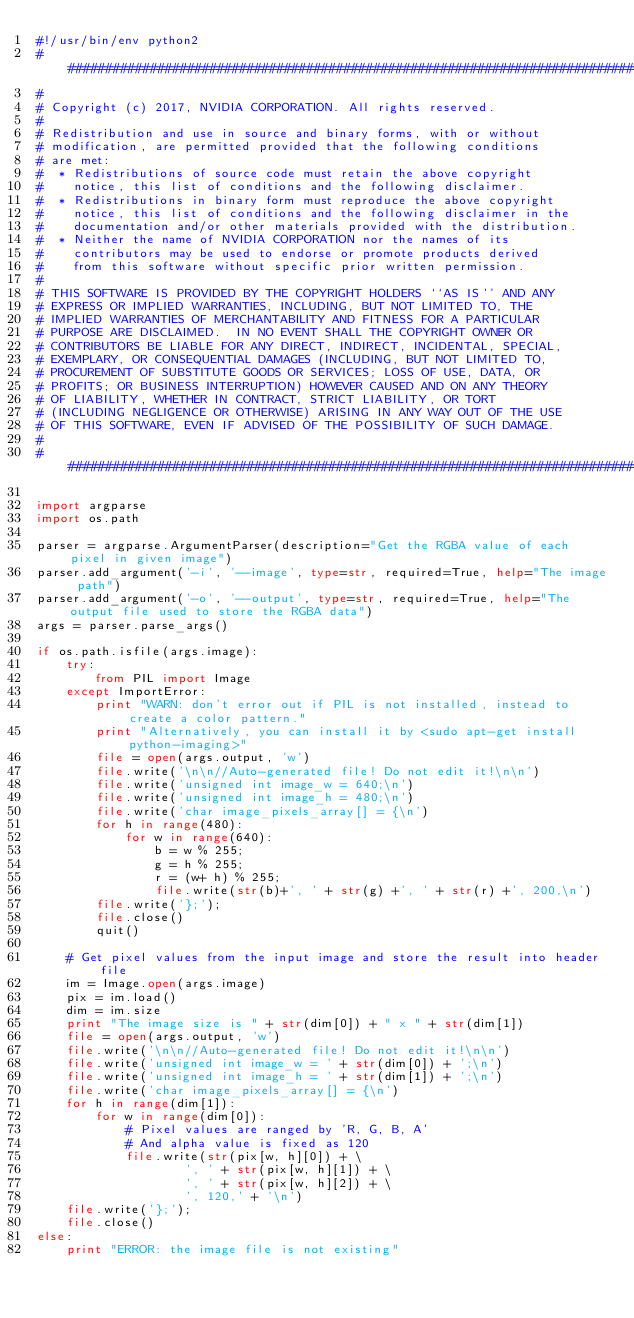<code> <loc_0><loc_0><loc_500><loc_500><_Python_>#!/usr/bin/env python2
###############################################################################
#
# Copyright (c) 2017, NVIDIA CORPORATION. All rights reserved.
#
# Redistribution and use in source and binary forms, with or without
# modification, are permitted provided that the following conditions
# are met:
#  * Redistributions of source code must retain the above copyright
#    notice, this list of conditions and the following disclaimer.
#  * Redistributions in binary form must reproduce the above copyright
#    notice, this list of conditions and the following disclaimer in the
#    documentation and/or other materials provided with the distribution.
#  * Neither the name of NVIDIA CORPORATION nor the names of its
#    contributors may be used to endorse or promote products derived
#    from this software without specific prior written permission.
#
# THIS SOFTWARE IS PROVIDED BY THE COPYRIGHT HOLDERS ``AS IS'' AND ANY
# EXPRESS OR IMPLIED WARRANTIES, INCLUDING, BUT NOT LIMITED TO, THE
# IMPLIED WARRANTIES OF MERCHANTABILITY AND FITNESS FOR A PARTICULAR
# PURPOSE ARE DISCLAIMED.  IN NO EVENT SHALL THE COPYRIGHT OWNER OR
# CONTRIBUTORS BE LIABLE FOR ANY DIRECT, INDIRECT, INCIDENTAL, SPECIAL,
# EXEMPLARY, OR CONSEQUENTIAL DAMAGES (INCLUDING, BUT NOT LIMITED TO,
# PROCUREMENT OF SUBSTITUTE GOODS OR SERVICES; LOSS OF USE, DATA, OR
# PROFITS; OR BUSINESS INTERRUPTION) HOWEVER CAUSED AND ON ANY THEORY
# OF LIABILITY, WHETHER IN CONTRACT, STRICT LIABILITY, OR TORT
# (INCLUDING NEGLIGENCE OR OTHERWISE) ARISING IN ANY WAY OUT OF THE USE
# OF THIS SOFTWARE, EVEN IF ADVISED OF THE POSSIBILITY OF SUCH DAMAGE.
#
###############################################################################

import argparse
import os.path

parser = argparse.ArgumentParser(description="Get the RGBA value of each pixel in given image")
parser.add_argument('-i', '--image', type=str, required=True, help="The image path")
parser.add_argument('-o', '--output', type=str, required=True, help="The output file used to store the RGBA data")
args = parser.parse_args()

if os.path.isfile(args.image):
    try:
        from PIL import Image
    except ImportError:
        print "WARN: don't error out if PIL is not installed, instead to create a color pattern."
        print "Alternatively, you can install it by <sudo apt-get install python-imaging>"
        file = open(args.output, 'w')
        file.write('\n\n//Auto-generated file! Do not edit it!\n\n')
        file.write('unsigned int image_w = 640;\n')
        file.write('unsigned int image_h = 480;\n')
        file.write('char image_pixels_array[] = {\n')
        for h in range(480):
            for w in range(640):
                b = w % 255;
                g = h % 255;
                r = (w+ h) % 255;
                file.write(str(b)+', ' + str(g) +', ' + str(r) +', 200,\n')
        file.write('};');
        file.close()
        quit()

    # Get pixel values from the input image and store the result into header file
    im = Image.open(args.image)
    pix = im.load()
    dim = im.size
    print "The image size is " + str(dim[0]) + " x " + str(dim[1])
    file = open(args.output, 'w')
    file.write('\n\n//Auto-generated file! Do not edit it!\n\n')
    file.write('unsigned int image_w = ' + str(dim[0]) + ';\n')
    file.write('unsigned int image_h = ' + str(dim[1]) + ';\n')
    file.write('char image_pixels_array[] = {\n')
    for h in range(dim[1]):
        for w in range(dim[0]):
            # Pixel values are ranged by 'R, G, B, A'
            # And alpha value is fixed as 120
            file.write(str(pix[w, h][0]) + \
                    ', ' + str(pix[w, h][1]) + \
                    ', ' + str(pix[w, h][2]) + \
                    ', 120,' + '\n')
    file.write('};');
    file.close()
else:
    print "ERROR: the image file is not existing"
</code> 